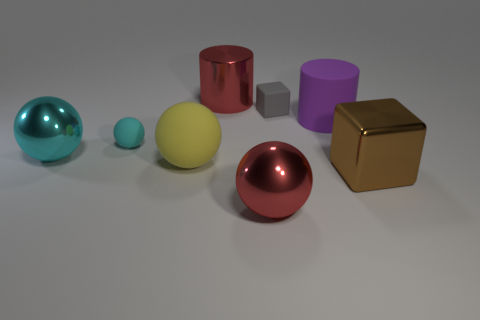Add 2 big balls. How many objects exist? 10 Subtract all brown cubes. How many cyan balls are left? 2 Subtract all tiny balls. How many balls are left? 3 Subtract 1 spheres. How many spheres are left? 3 Subtract all red spheres. How many spheres are left? 3 Subtract all cylinders. How many objects are left? 6 Subtract all gray cylinders. Subtract all large red cylinders. How many objects are left? 7 Add 3 big red metal spheres. How many big red metal spheres are left? 4 Add 1 gray matte cubes. How many gray matte cubes exist? 2 Subtract 0 blue blocks. How many objects are left? 8 